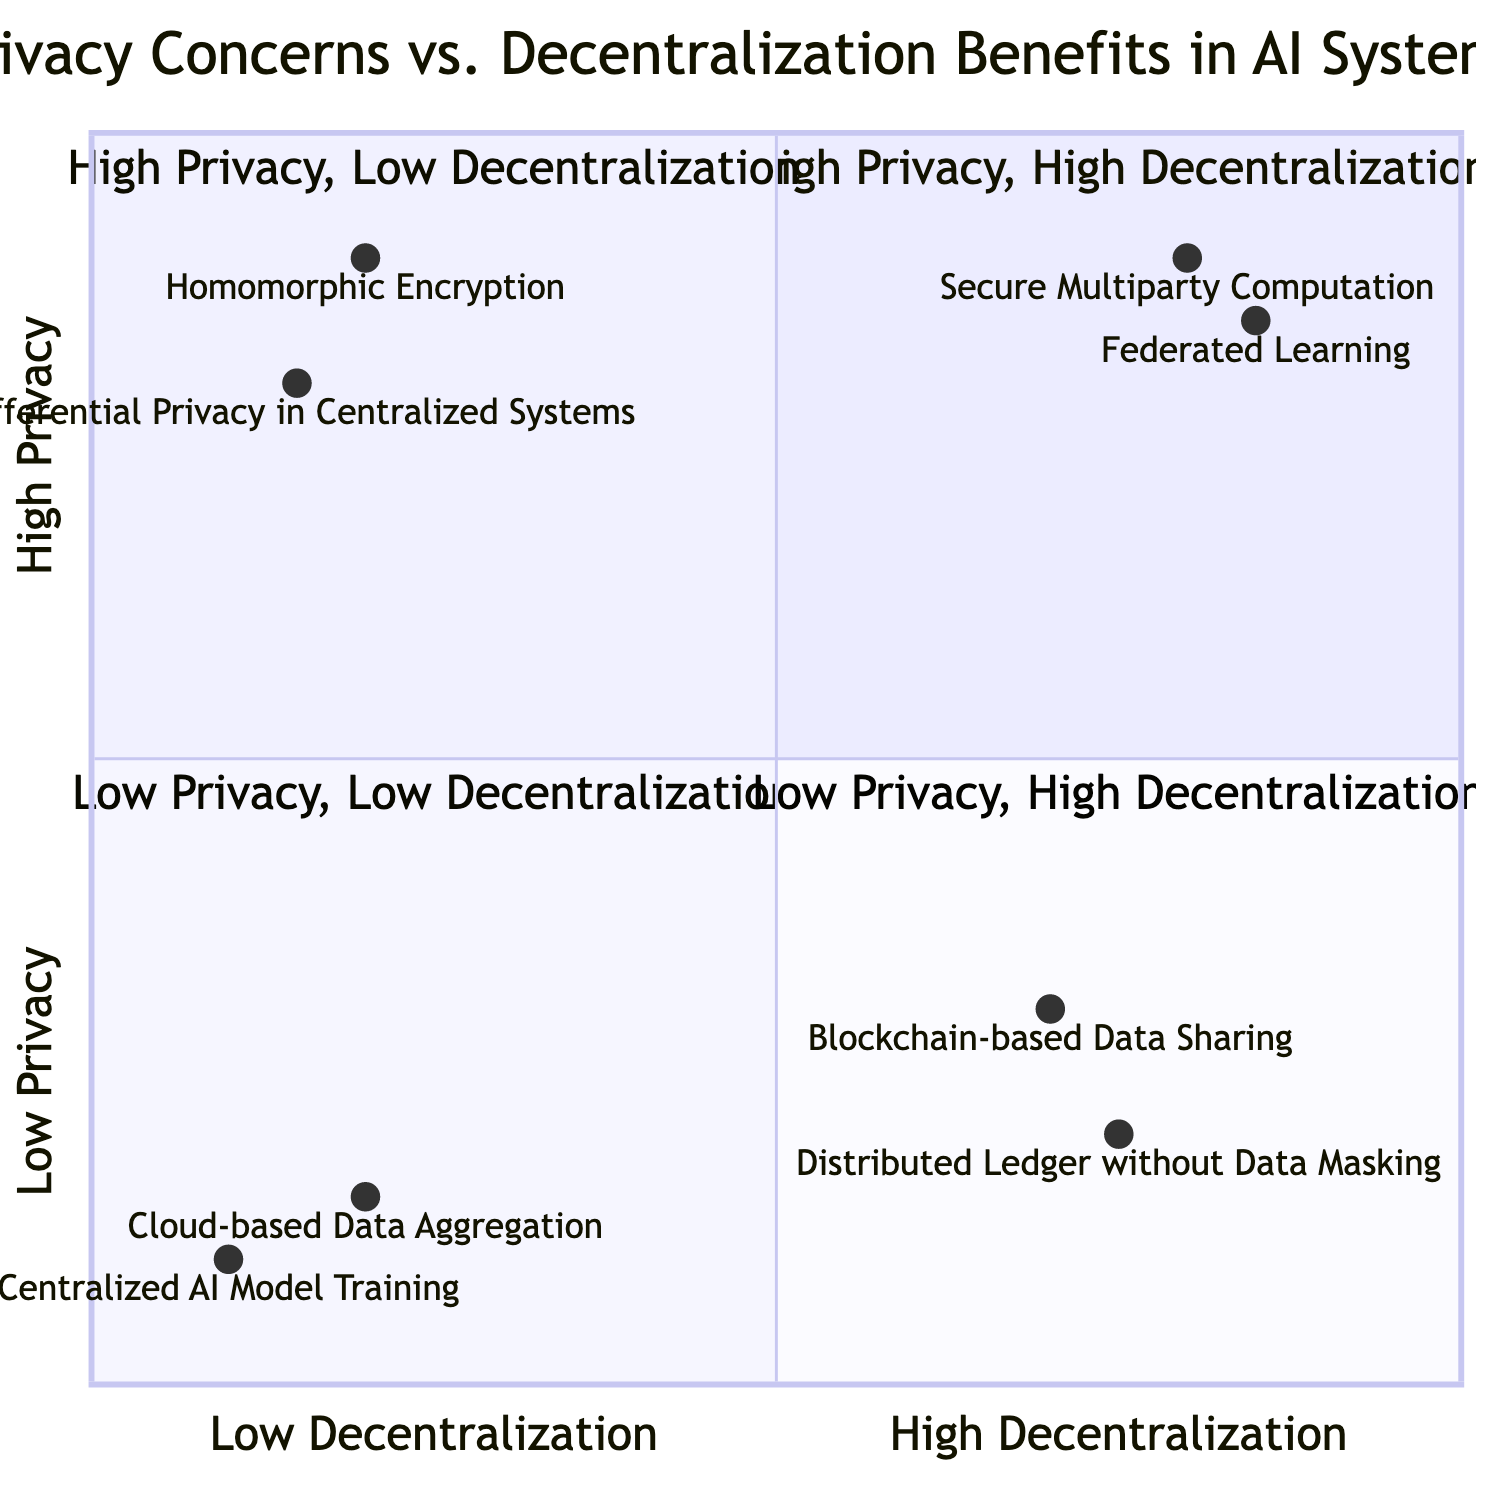What are the two methods in the high privacy, high decentralization quadrant? The high privacy, high decentralization quadrant contains "Secure Multiparty Computation" and "Federated Learning."
Answer: Secure Multiparty Computation, Federated Learning How many methods are located in the low privacy, low decentralization quadrant? There are two methods in the low privacy, low decentralization quadrant: "Centralized AI Model Training" and "Cloud-based Data Aggregation."
Answer: 2 Which method has the highest privacy rating? "Secure Multiparty Computation" has the highest privacy rating at 0.9.
Answer: Secure Multiparty Computation What is the privacy rating of "Blockchain-based Data Sharing"? The privacy rating of "Blockchain-based Data Sharing" is 0.3.
Answer: 0.3 Which quadrant contains methods characterized by low privacy and high decentralization? The low privacy, high decentralization quadrant contains "Blockchain-based Data Sharing" and "Distributed Ledger without Data Masking."
Answer: Low Privacy, High Decentralization Name one method in the high privacy, low decentralization quadrant. One method in the high privacy, low decentralization quadrant is "Homomorphic Encryption."
Answer: Homomorphic Encryption How does the privacy rating of "Federated Learning" compare to that of "Homomorphic Encryption"? "Federated Learning" has a privacy rating of 0.85, compared to "Homomorphic Encryption," which has a privacy rating of 0.9. Therefore, it has a lower rating.
Answer: Lower What is the decentralization rating of "Centralized AI Model Training"? The decentralization rating of "Centralized AI Model Training" is 0.1.
Answer: 0.1 Which method in the low privacy, high decentralization quadrant has the lowest privacy rating? "Distributed Ledger without Data Masking" has the lowest privacy rating at 0.2.
Answer: Distributed Ledger without Data Masking 